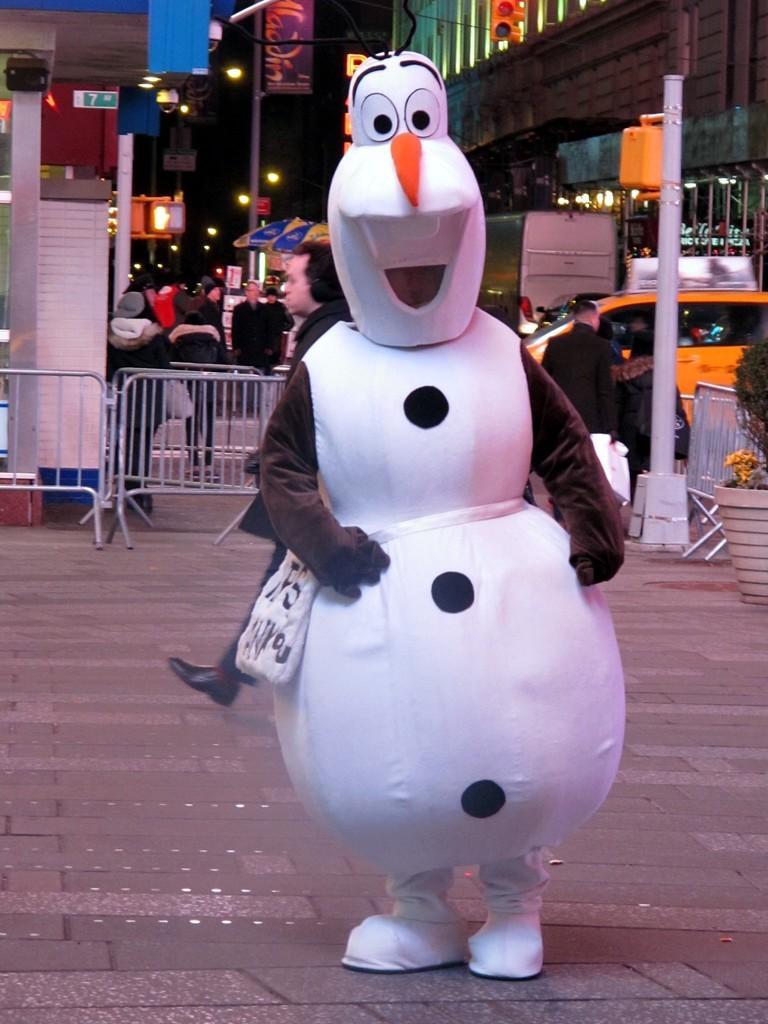Could you give a brief overview of what you see in this image? In this image in the foreground there is one person who is wearing a costume, and in the background there is a railing and group of persons, vehicles, poles, lights, buildings and some other objects. At the bottom there is walkway, on the right side there is flower pot and plant. 